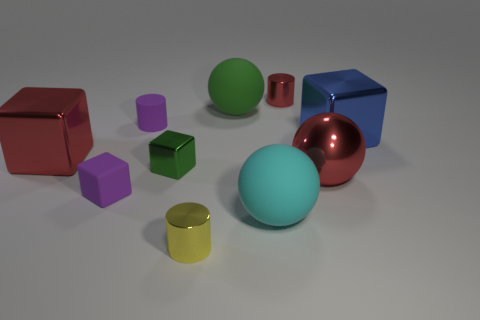Is the number of metallic things on the left side of the large cyan ball less than the number of tiny gray matte balls?
Your answer should be very brief. No. What size is the cylinder that is behind the big green ball behind the big blue metal thing?
Ensure brevity in your answer.  Small. How many things are either big blue metal objects or large rubber balls?
Provide a short and direct response. 3. Is there a cylinder of the same color as the rubber cube?
Ensure brevity in your answer.  Yes. Is the number of large red things less than the number of tiny red things?
Offer a very short reply. No. What number of objects are either tiny green objects or red metallic things on the right side of the red metal cylinder?
Keep it short and to the point. 2. Are there any spheres made of the same material as the purple cylinder?
Your response must be concise. Yes. What material is the purple cube that is the same size as the yellow cylinder?
Offer a terse response. Rubber. What is the material of the big red thing to the right of the large cyan sphere right of the red metal block?
Your answer should be very brief. Metal. Is the shape of the large thing left of the small matte block the same as  the big cyan matte thing?
Ensure brevity in your answer.  No. 